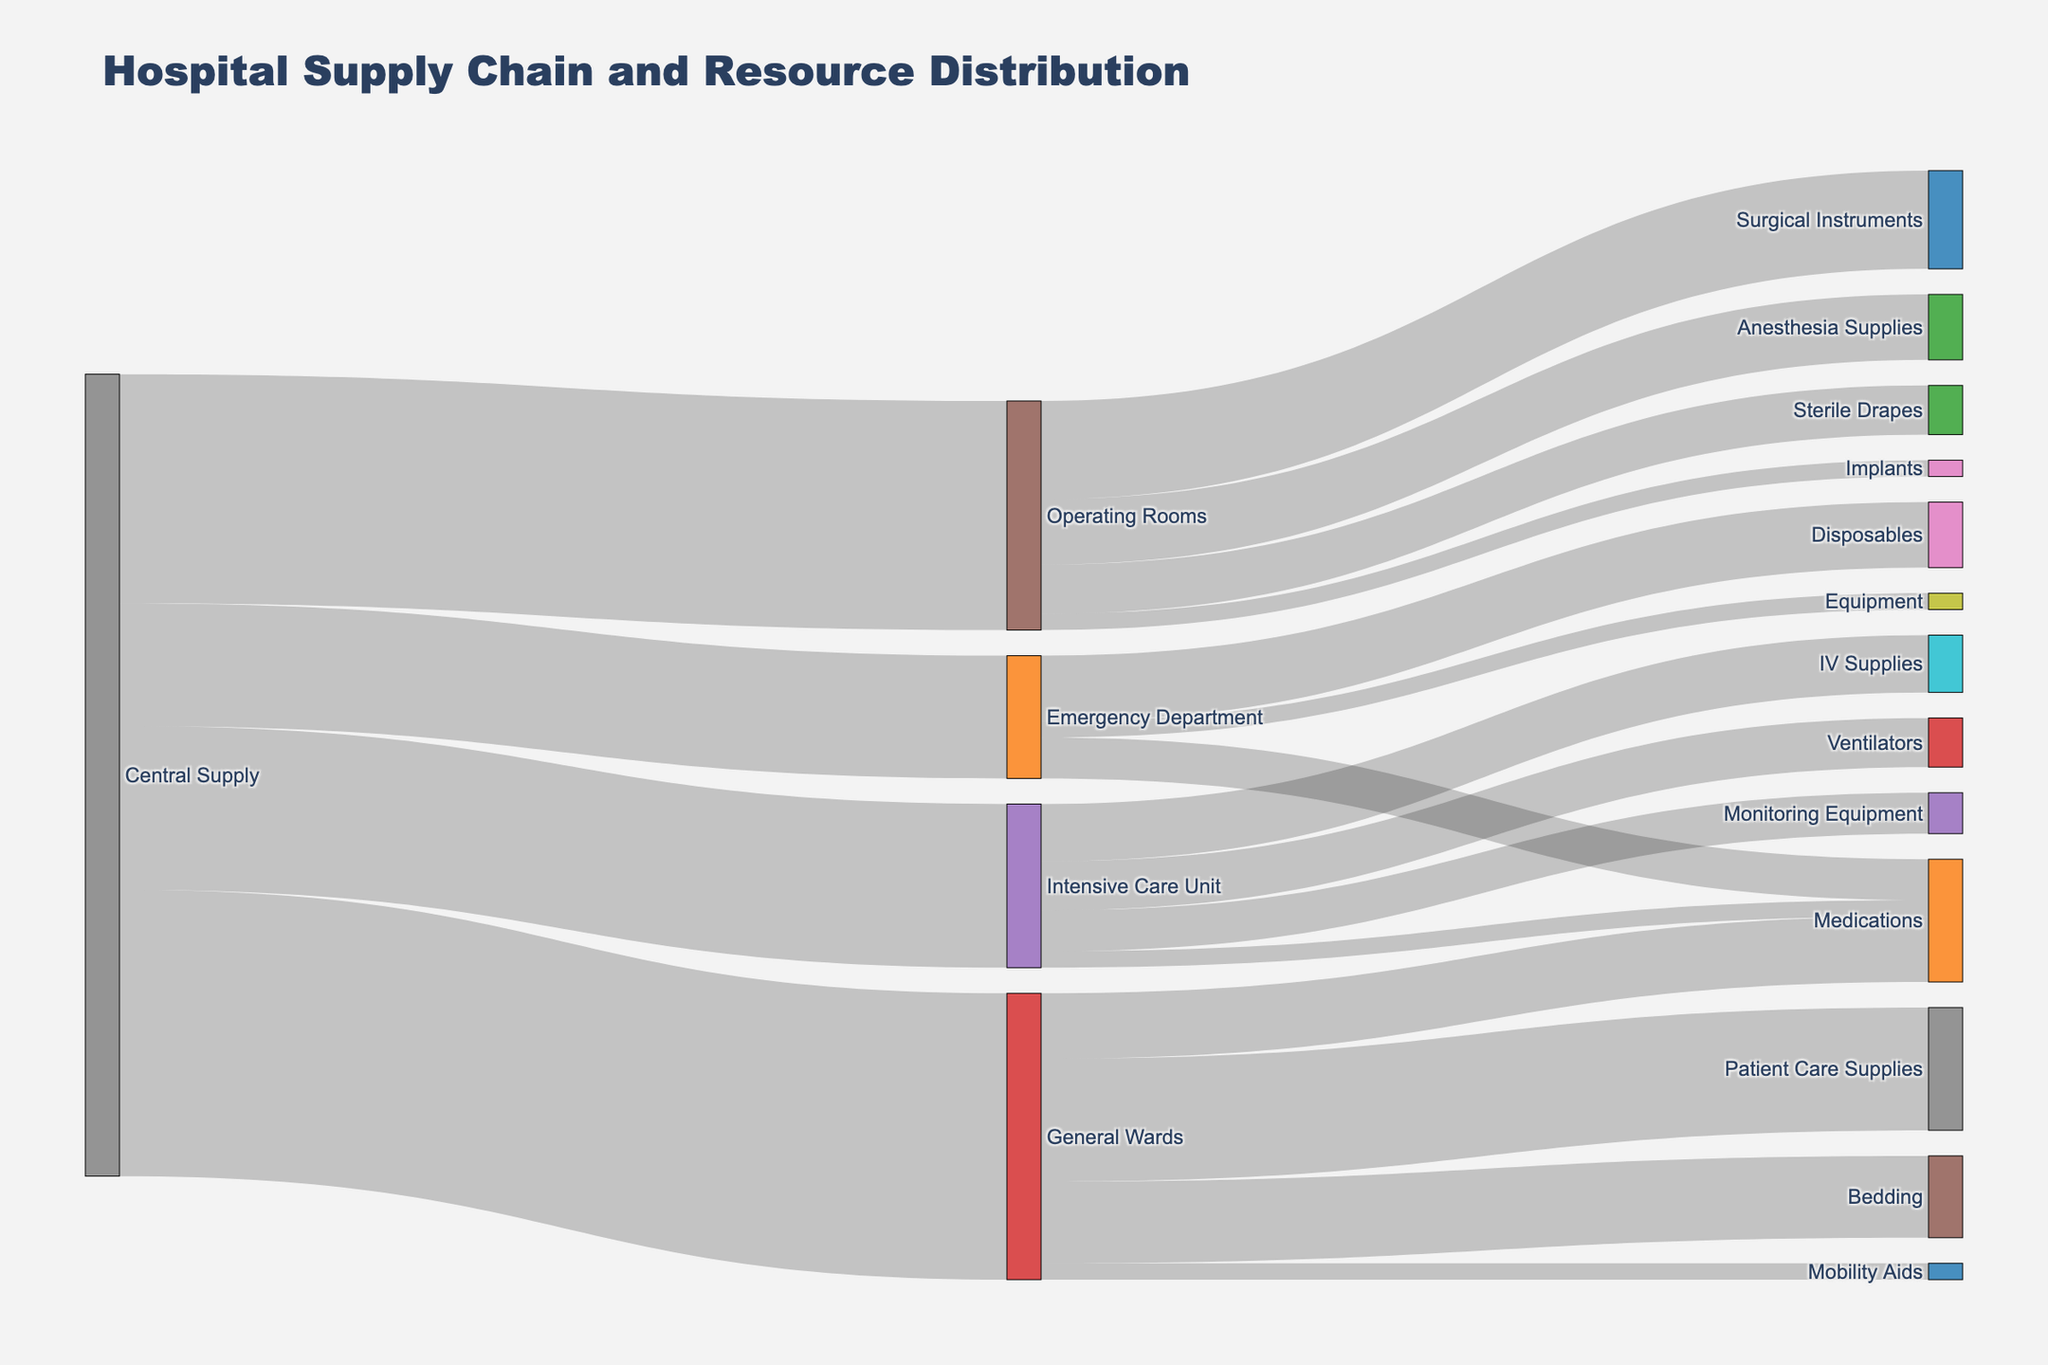What is the total value of supplies sent from the Central Supply to all departments? The figure shows the Central Supply distributing supplies to the Emergency Department, Operating Rooms, Intensive Care Unit, and General Wards. Summing the values: 1500 (Emergency Department) + 2800 (Operating Rooms) + 2000 (Intensive Care Unit) + 3500 (General Wards) = 9800
Answer: 9800 How many types of resources does the Emergency Department receive, and what are they? The figure shows the Emergency Department receiving Disposables, Medications, and Equipment. The total number of resource types received is three: Disposables, Medications, Equipment
Answer: 3; Disposables, Medications, Equipment Which department receives the largest amount of supplies from the Central Supply? By inspecting the values, the General Wards receive the largest amount from the Central Supply, at 3500
Answer: General Wards What is the total value of medications received by all departments? The figure shows values of Medications received by the Emergency Department (500), Intensive Care Unit (200), and General Wards (800), summing them gives 500 + 200 + 800 = 1500
Answer: 1500 Compare the value of supplies received by the Intensive Care Unit and the Operating Rooms from the Central Supply. Which receives more and by how much? The Intensive Care Unit receives 2000 from the Central Supply, while the Operating Rooms receive 2800. The difference is 2800 - 2000 = 800, with the Operating Rooms receiving more
Answer: Operating Rooms, by 800 What specific supplies does the Intensive Care Unit receive, and their corresponding values? The Intensive Care Unit receives Ventilators (600), Monitoring Equipment (500), IV Supplies (700), and Medications (200) as shown in the figure
Answer: Ventilators: 600, Monitoring Equipment: 500, IV Supplies: 700, Medications: 200 What is the total value of supplies going to the Operating Rooms and what types are they? The Operating Rooms receive Surgical Instruments (1200), Anesthesia Supplies (800), Sterile Drapes (600), and Implants (200). Summing these values: 1200 + 800 + 600 + 200 = 2800
Answer: 2800; Surgical Instruments, Anesthesia Supplies, Sterile Drapes, Implants How does the amount of Bedding received by the General Wards compare to the amount of Disposables received by the Emergency Department? The General Wards receive Bedding valued at 1000, while the Emergency Department receives Disposables valued at 800. The difference is 1000 - 800 = 200, with Bedding being more
Answer: Bedding by 200 What is the smallest value of supplies received by any department from the Central Supply, and which department receives it? By examining the values, the smallest value received from the Central Supply is 1500 by the Emergency Department
Answer: 1500; Emergency Department How many distinct types of resources does the hospital handle in total according to the figure? The figure lists Disposables, Medications, Equipment, Surgical Instruments, Anesthesia Supplies, Sterile Drapes, Implants, Ventilators, Monitoring Equipment, IV Supplies, Bedding, Patient Care Supplies, and Mobility Aids. Counting unique types, there are 13
Answer: 13 